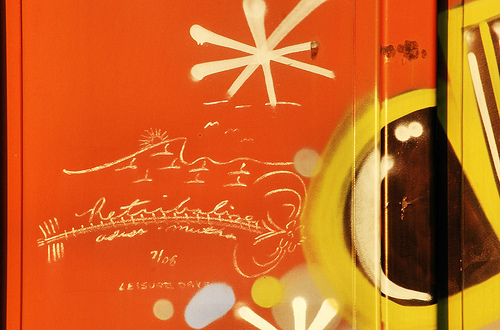<image>
Can you confirm if the sun is above the date? Yes. The sun is positioned above the date in the vertical space, higher up in the scene. 